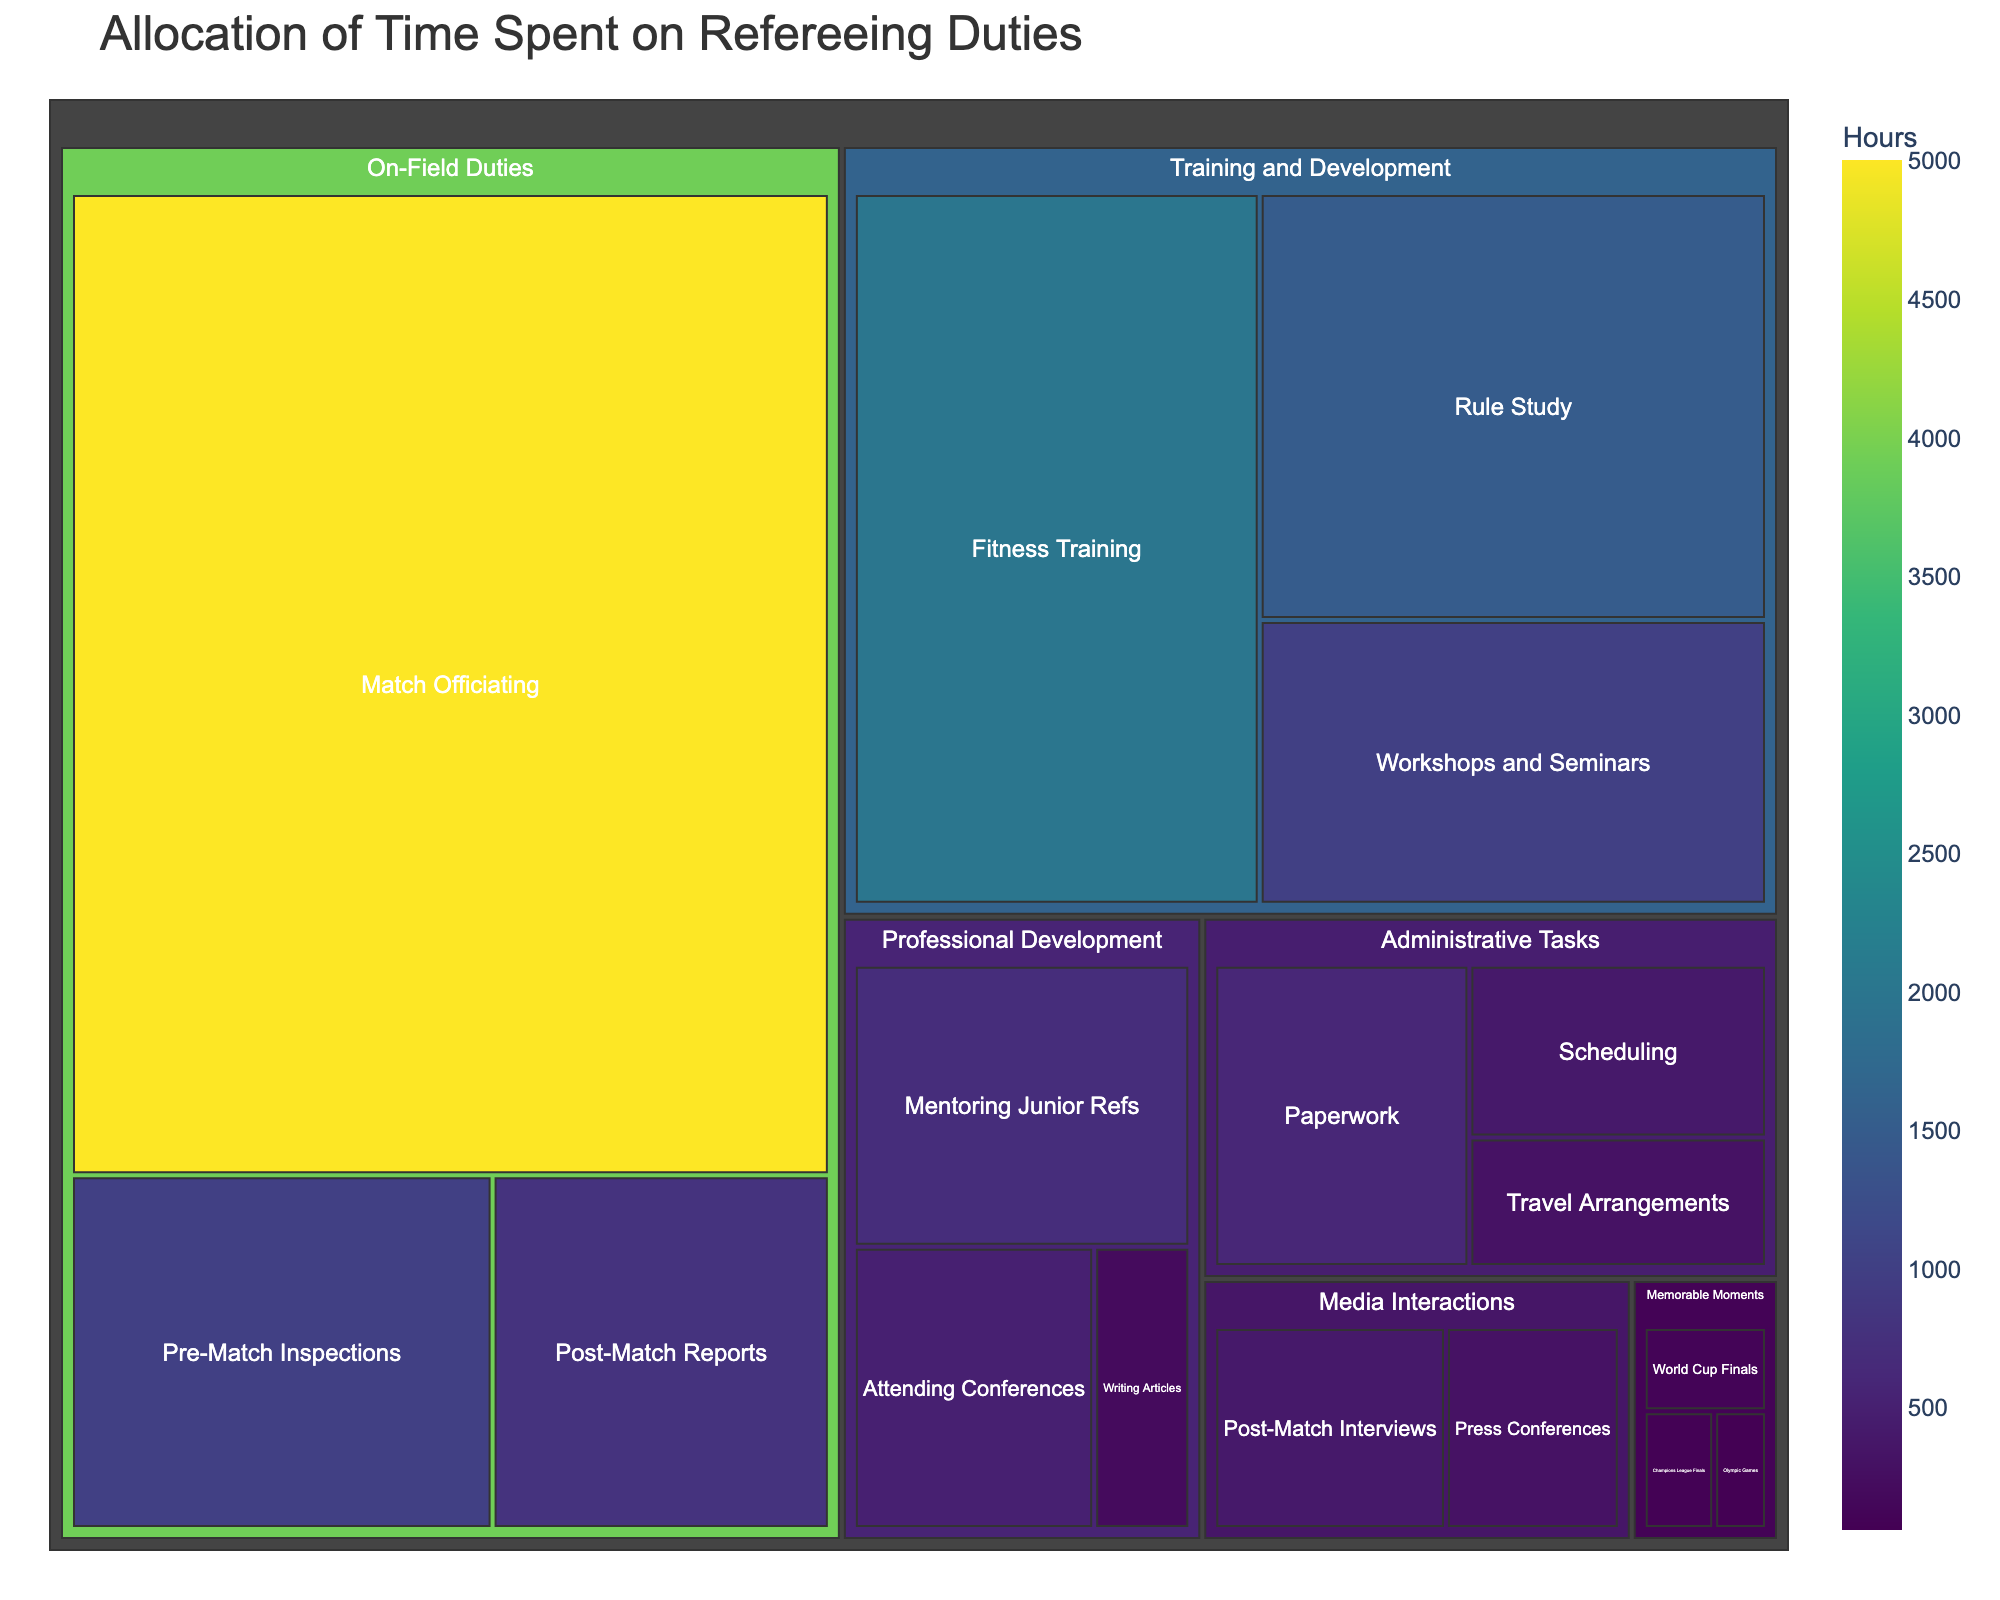How many hours were spent on Training and Development tasks in total? To determine the total hours spent on Training and Development tasks, sum the hours in each subcategory (Fitness Training, Rule Study, Workshops and Seminars). The calculation is 2000 + 1500 + 1000 = 4500 hours.
Answer: 4500 Which subcategory in On-Field Duties took the most time? Looking at the On-Field Duties category, compare the hours for Match Officiating, Pre-Match Inspections, and Post-Match Reports. Match Officiating has the highest time allocation with 5000 hours.
Answer: Match Officiating What is the total time spent on Administrative Tasks? To find the total time spent on Administrative Tasks, sum the hours for Paperwork, Scheduling, and Travel Arrangements. The sum is 600 + 400 + 300 = 1300 hours.
Answer: 1300 How does the time spent on Fitness Training compare to the time spent on Rule Study? Compare the hours for Fitness Training and Rule Study under Training and Development. Fitness Training has 2000 hours and Rule Study has 1500 hours, so Fitness Training has more hours.
Answer: Fitness Training has more hours What is the smallest subcategory in terms of hours in the entire treemap? Identify the subcategory with the fewest hours by comparing all the listed subcategories. Olympic Games has the lowest value with 60 hours.
Answer: Olympic Games How many hours in total are allocated to Professional Development? Sum the hours of all subcategories under Professional Development: Mentoring Junior Refs, Attending Conferences, and Writing Articles. The total is 700 + 500 + 200 = 1400 hours.
Answer: 1400 What is the average time spent on Media Interactions tasks? To find the average, add the hours for Post-Match Interviews and Press Conferences, then divide by the number of subcategories. The calculation is (400 + 300) / 2 = 350 hours.
Answer: 350 Which category is allocated the largest portion of time? Sum the hours for each top-level category and compare. On-Field Duties has the highest total with 6800 hours (Match Officiating, Pre-Match Inspections, Post-Match Reports).
Answer: On-Field Duties How do the hours spent on memorable moments like World Cup Finals, Champions League Finals, and Olympic Games compare collectively to other categories? Add the hours of World Cup Finals, Champions League Finals, and Olympic Games (100 + 80 + 60 = 240 hours) and compare this sum to the total hours of the other categories. Other categories have much higher collective totals.
Answer: Much lower than any other category Which subcategory within the Media Interactions category has more hours? Compare the hours between Post-Match Interviews and Press Conferences under Media Interactions. Post-Match Interviews has 400 hours, which is higher than Press Conferences with 300 hours.
Answer: Post-Match Interviews 